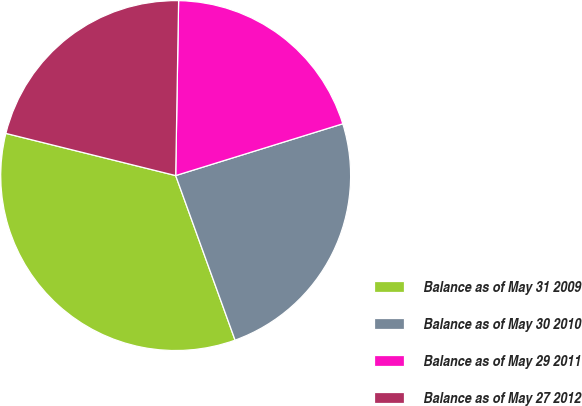<chart> <loc_0><loc_0><loc_500><loc_500><pie_chart><fcel>Balance as of May 31 2009<fcel>Balance as of May 30 2010<fcel>Balance as of May 29 2011<fcel>Balance as of May 27 2012<nl><fcel>34.39%<fcel>24.27%<fcel>19.95%<fcel>21.39%<nl></chart> 